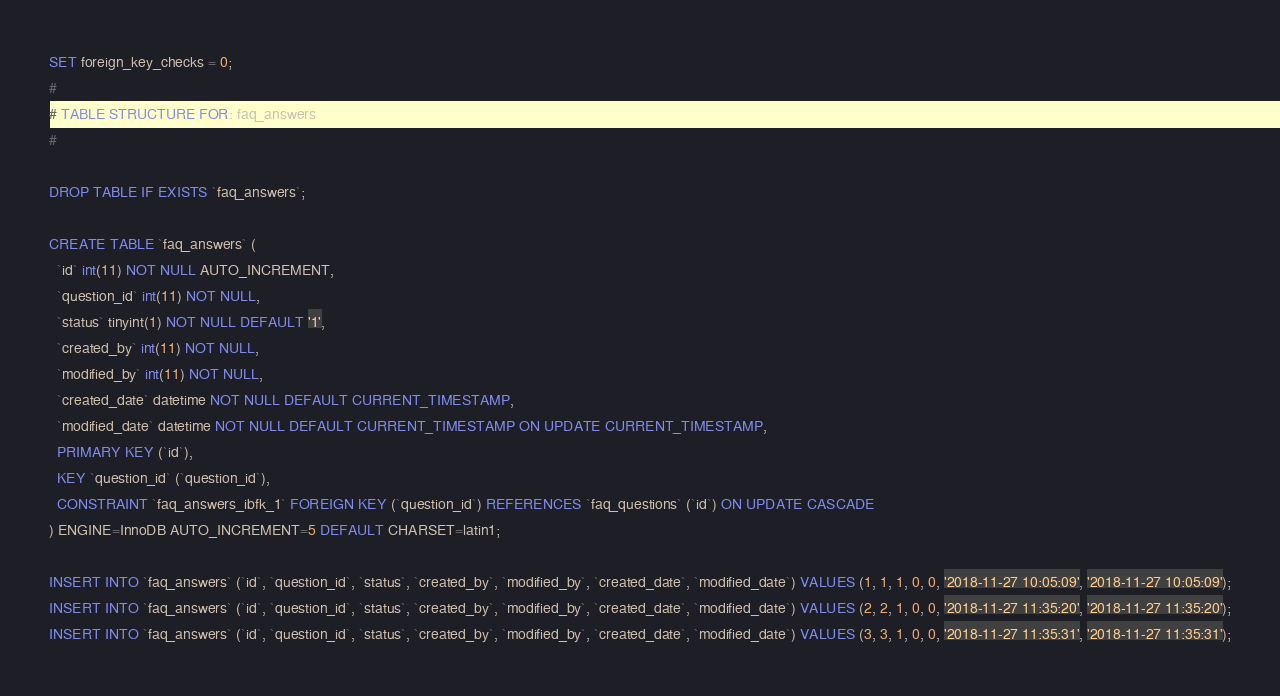<code> <loc_0><loc_0><loc_500><loc_500><_SQL_>SET foreign_key_checks = 0;
#
# TABLE STRUCTURE FOR: faq_answers
#

DROP TABLE IF EXISTS `faq_answers`;

CREATE TABLE `faq_answers` (
  `id` int(11) NOT NULL AUTO_INCREMENT,
  `question_id` int(11) NOT NULL,
  `status` tinyint(1) NOT NULL DEFAULT '1',
  `created_by` int(11) NOT NULL,
  `modified_by` int(11) NOT NULL,
  `created_date` datetime NOT NULL DEFAULT CURRENT_TIMESTAMP,
  `modified_date` datetime NOT NULL DEFAULT CURRENT_TIMESTAMP ON UPDATE CURRENT_TIMESTAMP,
  PRIMARY KEY (`id`),
  KEY `question_id` (`question_id`),
  CONSTRAINT `faq_answers_ibfk_1` FOREIGN KEY (`question_id`) REFERENCES `faq_questions` (`id`) ON UPDATE CASCADE
) ENGINE=InnoDB AUTO_INCREMENT=5 DEFAULT CHARSET=latin1;

INSERT INTO `faq_answers` (`id`, `question_id`, `status`, `created_by`, `modified_by`, `created_date`, `modified_date`) VALUES (1, 1, 1, 0, 0, '2018-11-27 10:05:09', '2018-11-27 10:05:09');
INSERT INTO `faq_answers` (`id`, `question_id`, `status`, `created_by`, `modified_by`, `created_date`, `modified_date`) VALUES (2, 2, 1, 0, 0, '2018-11-27 11:35:20', '2018-11-27 11:35:20');
INSERT INTO `faq_answers` (`id`, `question_id`, `status`, `created_by`, `modified_by`, `created_date`, `modified_date`) VALUES (3, 3, 1, 0, 0, '2018-11-27 11:35:31', '2018-11-27 11:35:31');</code> 